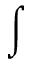<formula> <loc_0><loc_0><loc_500><loc_500>\int</formula> 